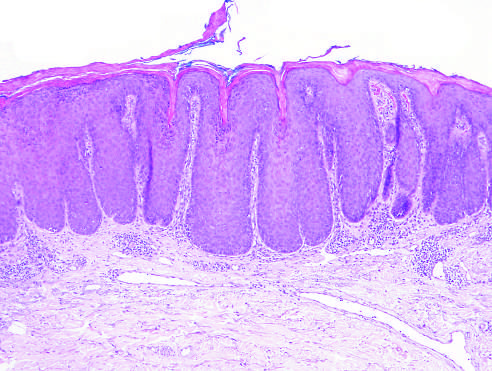re superficial dermal fibrosis and vascular ectasia, both common features, present?
Answer the question using a single word or phrase. Yes 